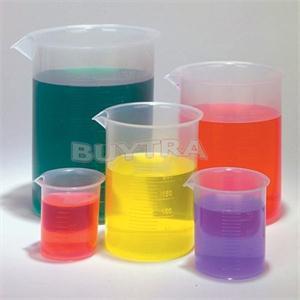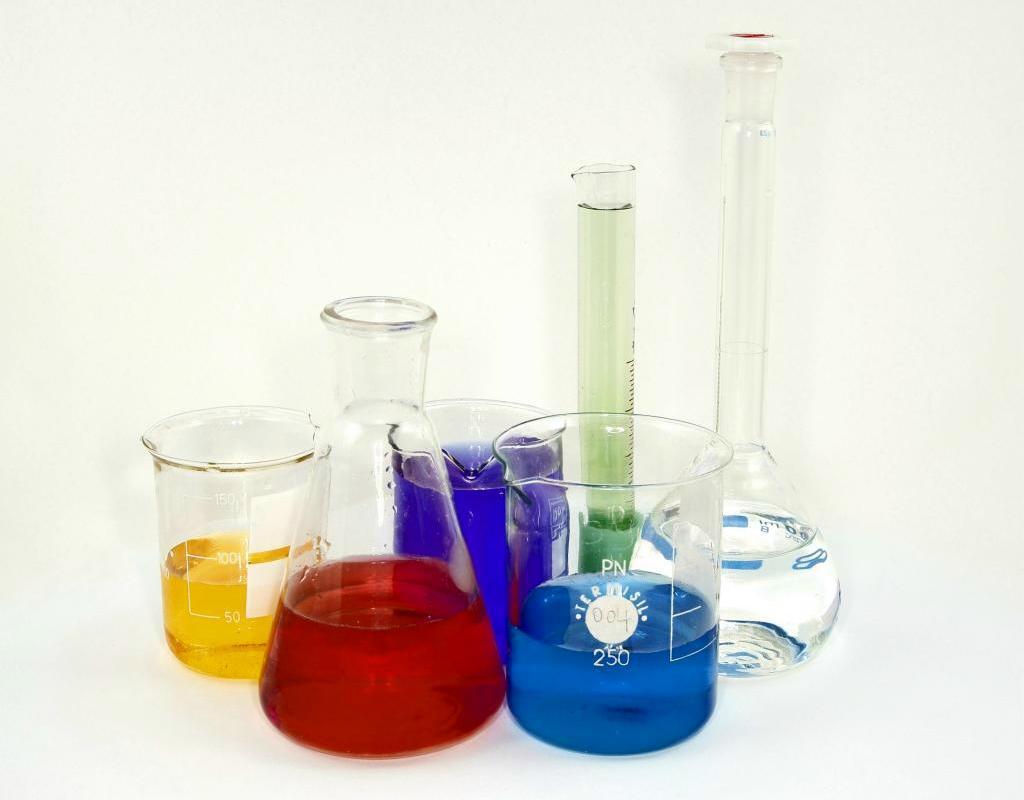The first image is the image on the left, the second image is the image on the right. Given the left and right images, does the statement "All of the upright beakers of various shapes contain colored liquids." hold true? Answer yes or no. No. The first image is the image on the left, the second image is the image on the right. For the images shown, is this caption "One image shows exactly five containers of liquid in varying sizes and includes the colors green, yellow, and purple." true? Answer yes or no. Yes. 